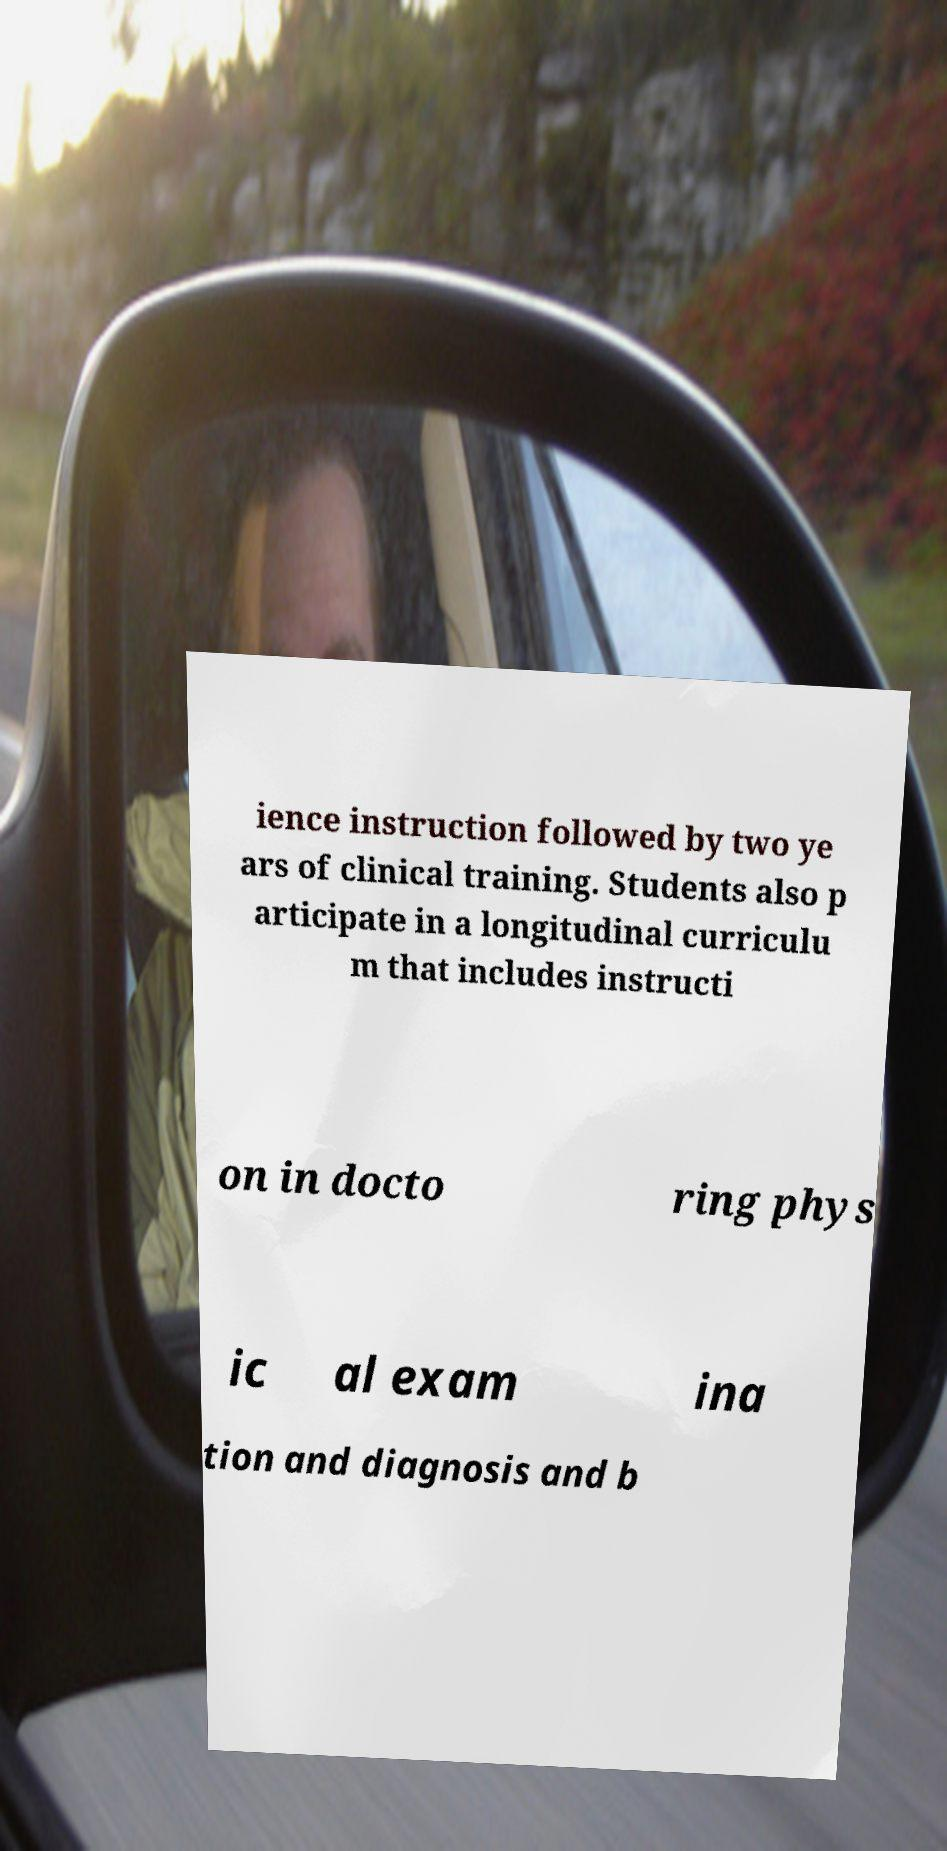Can you accurately transcribe the text from the provided image for me? ience instruction followed by two ye ars of clinical training. Students also p articipate in a longitudinal curriculu m that includes instructi on in docto ring phys ic al exam ina tion and diagnosis and b 